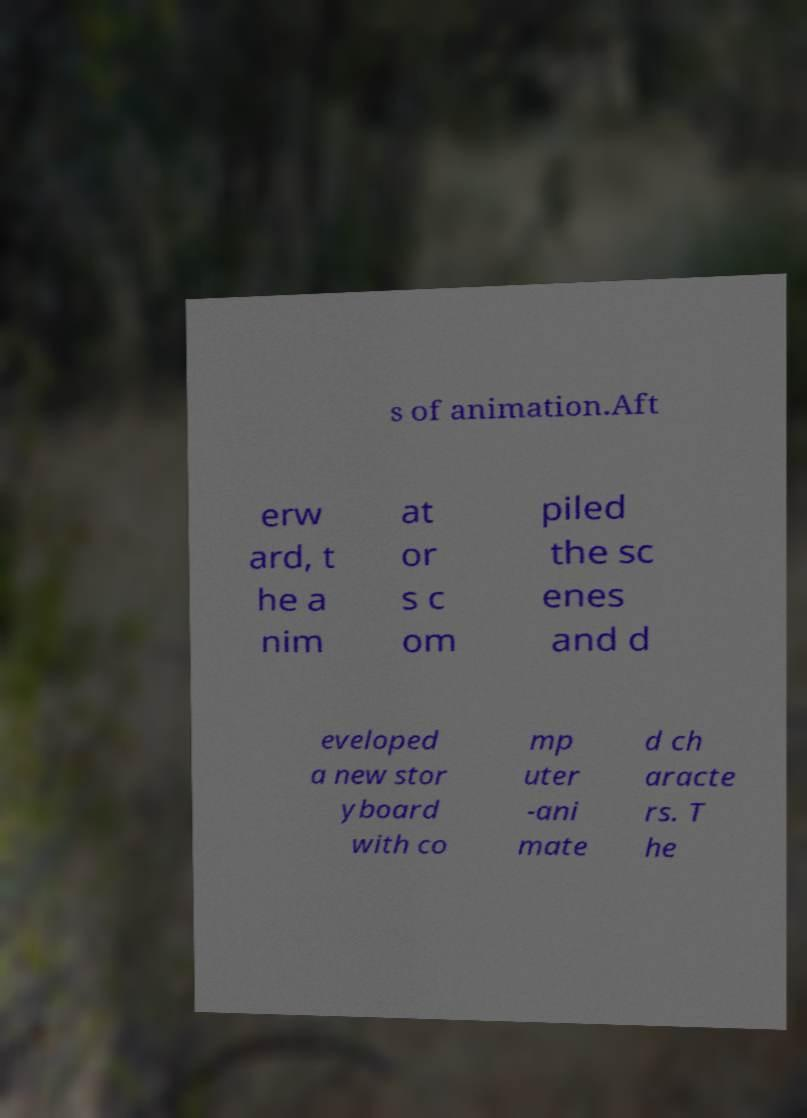Could you assist in decoding the text presented in this image and type it out clearly? s of animation.Aft erw ard, t he a nim at or s c om piled the sc enes and d eveloped a new stor yboard with co mp uter -ani mate d ch aracte rs. T he 